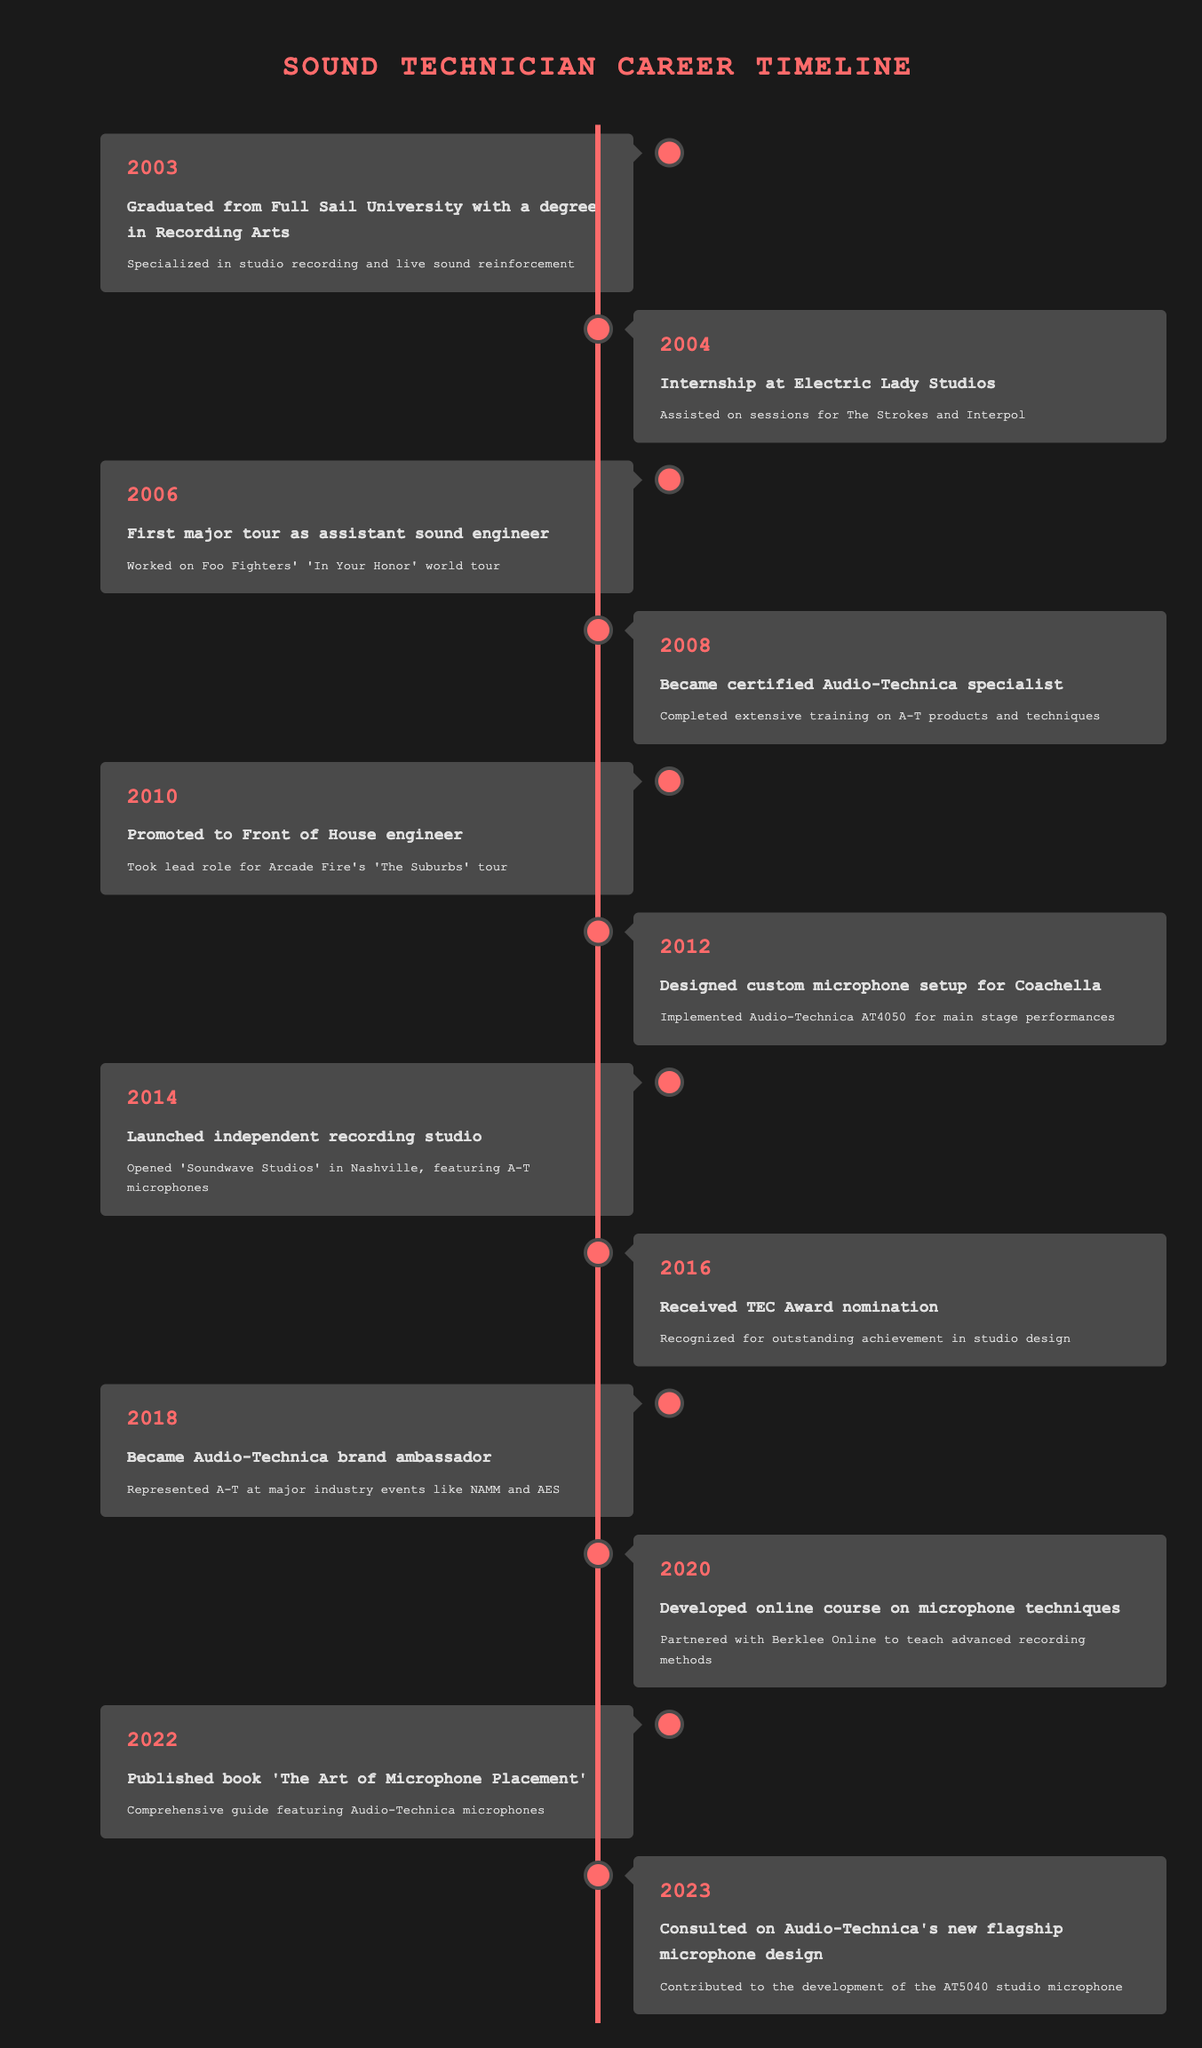What year did the sound technician graduate from Full Sail University? The table states that in 2003, the event was "Graduated from Full Sail University with a degree in Recording Arts." Thus, the answer can be directly retrieved from the timeline's 2003 entry.
Answer: 2003 Which event occurred immediately after the sound technician graduated? Looking at the timeline, the next event after 2003 (graduation) is in 2004, which states "Internship at Electric Lady Studios." This event is directly below the graduation entry.
Answer: Internship at Electric Lady Studios How many years passed between the sound technician's first major tour and the certification as an Audio-Technica specialist? The first major tour happened in 2006, and the certification was achieved in 2008. The difference in years is 2008 - 2006 = 2 years. This can be calculated by subtracting the years of the two events.
Answer: 2 years True or False: The sound technician published a book before launching an independent recording studio. The table shows that the book was published in 2022 and the studio was launched in 2014. Therefore, 2022 is after 2014, making the statement false.
Answer: False In what year did the technician become a brand ambassador for Audio-Technica? The timeline indicates that in 2018, the technician became an Audio-Technica brand ambassador. This event can be found directly in the 2018 entry.
Answer: 2018 What is the total number of distinct events mentioned in the timeline? Counting all the listed events in the timeline, there are 12 entries from 2003 to 2023. Therefore, summing these 12 individual events gives the total.
Answer: 12 What event occurred in 2016, and how does it relate to studio design? In 2016, the event recorded is "Received TEC Award nomination," which recognizes outstanding achievement in studio design. This directly relates to the technician's accomplishments in design and acknowledges their professional work.
Answer: Received TEC Award nomination Was the sound technician involved in any teaching capacity? Yes, according to the event from 2020, the technician developed an online course on microphone techniques in partnership with Berklee Online, which indicates involvement in teaching.
Answer: Yes What major achievement occurred in 2023, and how does it signify a culmination of expertise? In 2023, the technician consulted on Audio-Technica's new flagship microphone design. This signifies a culmination of expertise because it indicates a recognized contribution to product development, showcasing their extensive knowledge and experience accumulated over the years in the field.
Answer: Consulted on flagship microphone design 